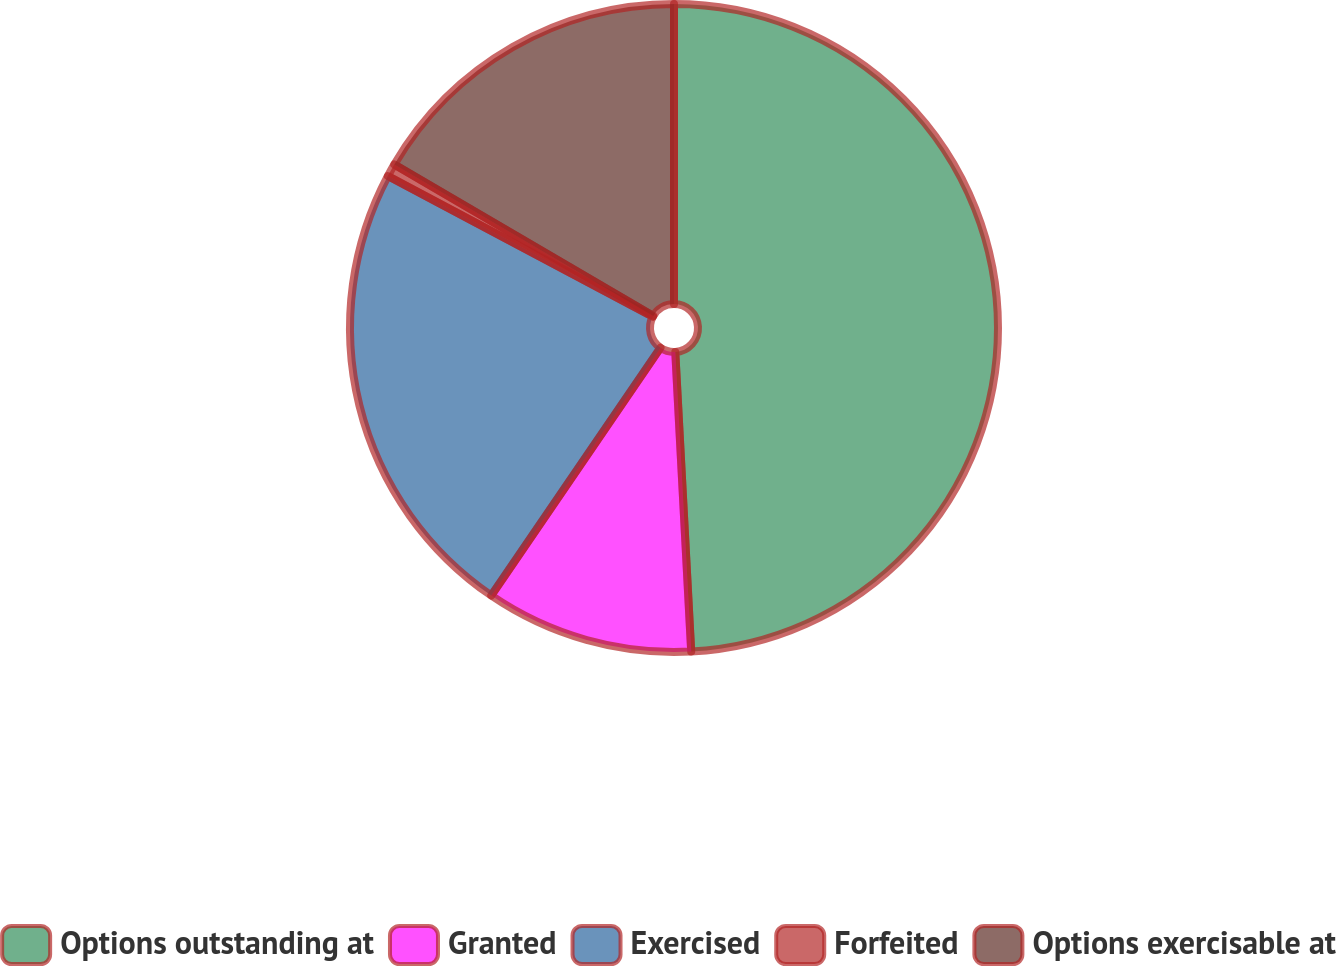<chart> <loc_0><loc_0><loc_500><loc_500><pie_chart><fcel>Options outstanding at<fcel>Granted<fcel>Exercised<fcel>Forfeited<fcel>Options exercisable at<nl><fcel>49.15%<fcel>10.38%<fcel>23.23%<fcel>0.65%<fcel>16.58%<nl></chart> 